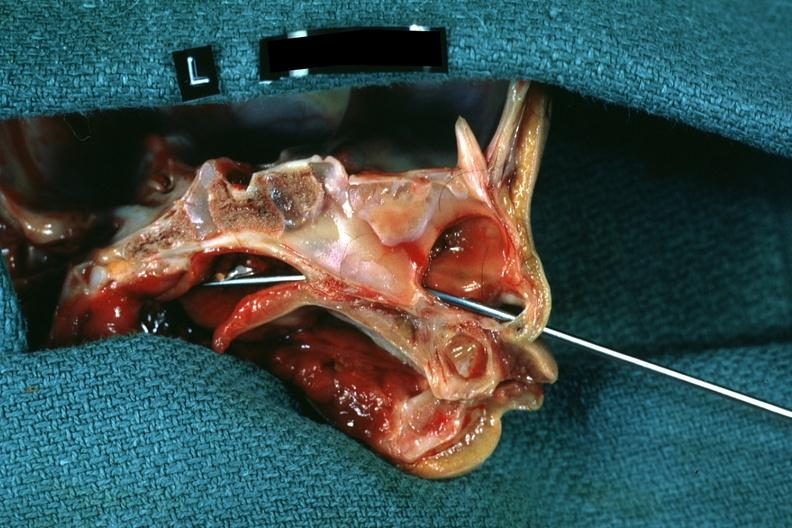s hemisection of nose left side showing patency right side was not patent?
Answer the question using a single word or phrase. Yes 